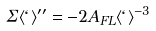<formula> <loc_0><loc_0><loc_500><loc_500>\Sigma \langle \ell \rangle ^ { \prime \prime } = - 2 A _ { F L } \langle \ell \rangle ^ { - 3 }</formula> 